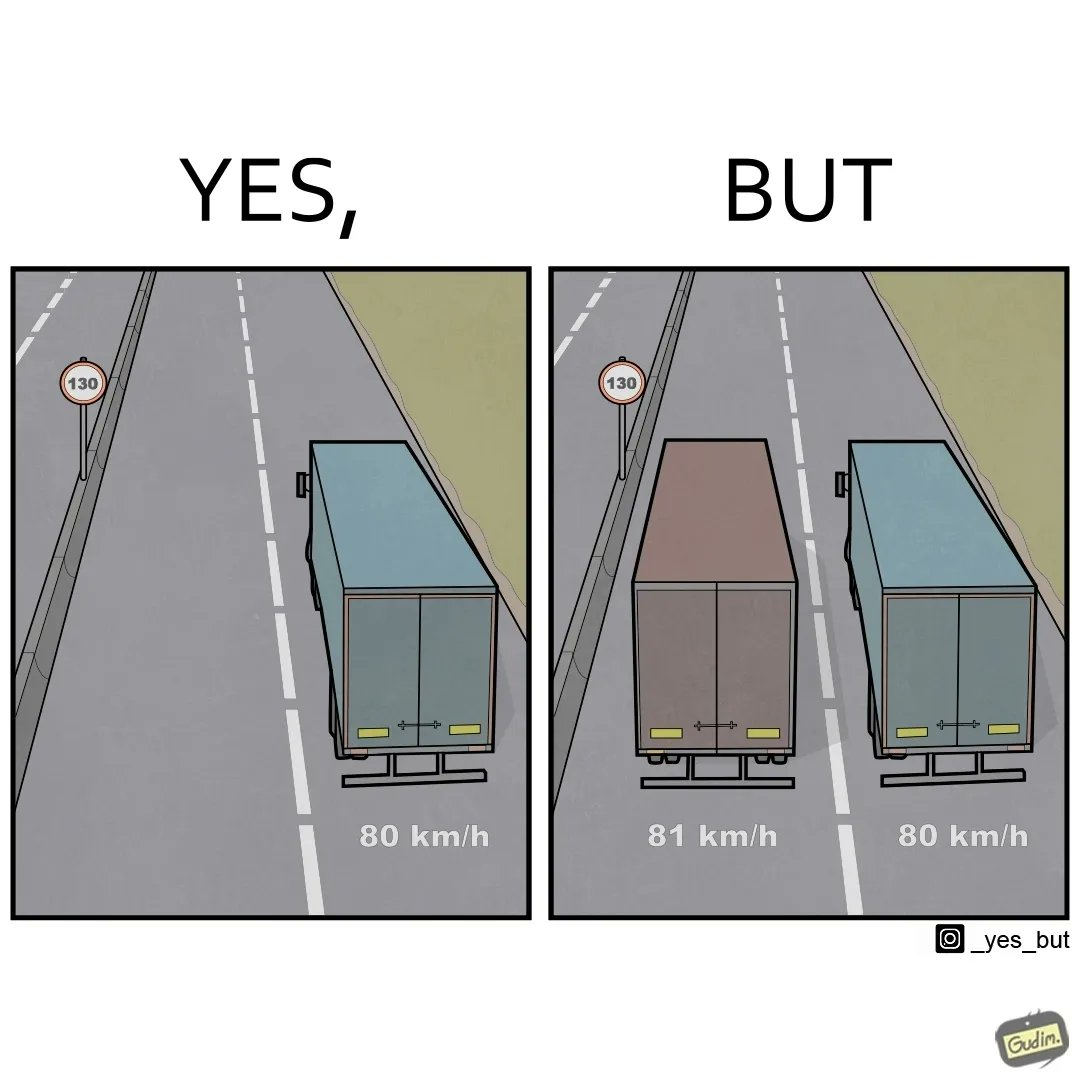Would you classify this image as satirical? Yes, this image is satirical. 